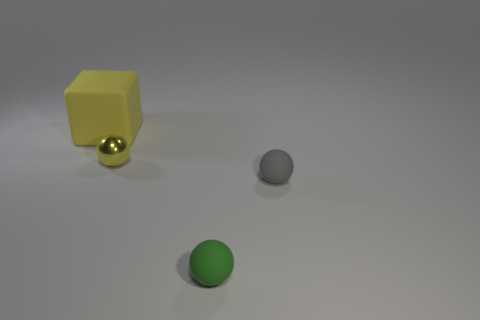Add 2 yellow blocks. How many objects exist? 6 Subtract all spheres. How many objects are left? 1 Add 4 green matte blocks. How many green matte blocks exist? 4 Subtract 1 gray balls. How many objects are left? 3 Subtract all cubes. Subtract all green balls. How many objects are left? 2 Add 1 large matte objects. How many large matte objects are left? 2 